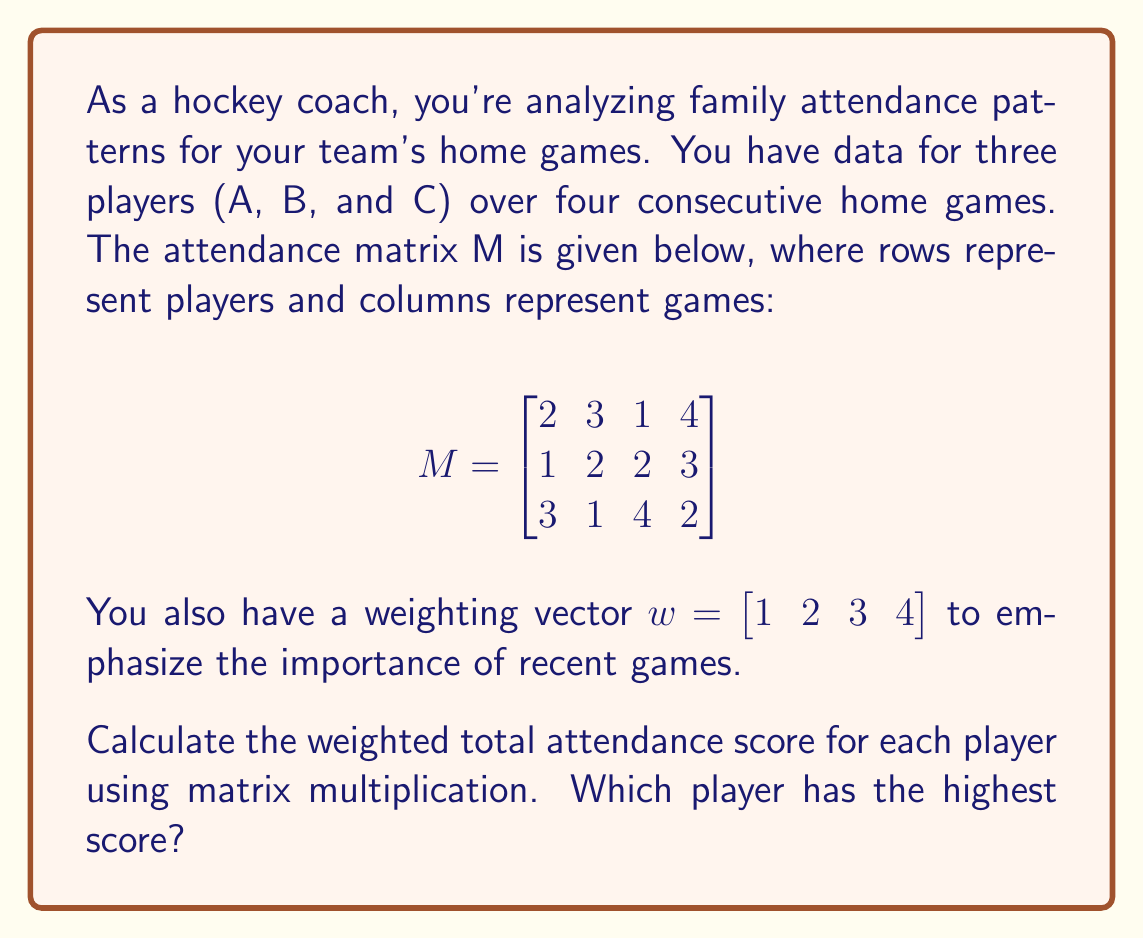What is the answer to this math problem? Let's approach this step-by-step:

1) We need to multiply the attendance matrix M by the transpose of the weighting vector w. This will give us a column vector with the weighted attendance score for each player.

2) First, let's transpose w:
   $$w^T = \begin{bmatrix} 1 \\ 2 \\ 3 \\ 4 \end{bmatrix}$$

3) Now, we perform the matrix multiplication:
   $$M \cdot w^T = \begin{bmatrix}
   2 & 3 & 1 & 4 \\
   1 & 2 & 2 & 3 \\
   3 & 1 & 4 & 2
   \end{bmatrix} \cdot \begin{bmatrix} 1 \\ 2 \\ 3 \\ 4 \end{bmatrix}$$

4) Let's calculate each element of the resulting vector:
   
   For Player A: $(2 \cdot 1) + (3 \cdot 2) + (1 \cdot 3) + (4 \cdot 4) = 2 + 6 + 3 + 16 = 27$
   
   For Player B: $(1 \cdot 1) + (2 \cdot 2) + (2 \cdot 3) + (3 \cdot 4) = 1 + 4 + 6 + 12 = 23$
   
   For Player C: $(3 \cdot 1) + (1 \cdot 2) + (4 \cdot 3) + (2 \cdot 4) = 3 + 2 + 12 + 8 = 25$

5) The resulting vector is:
   $$\begin{bmatrix} 27 \\ 23 \\ 25 \end{bmatrix}$$

6) The highest score is 27, corresponding to Player A.
Answer: Player A with a score of 27 